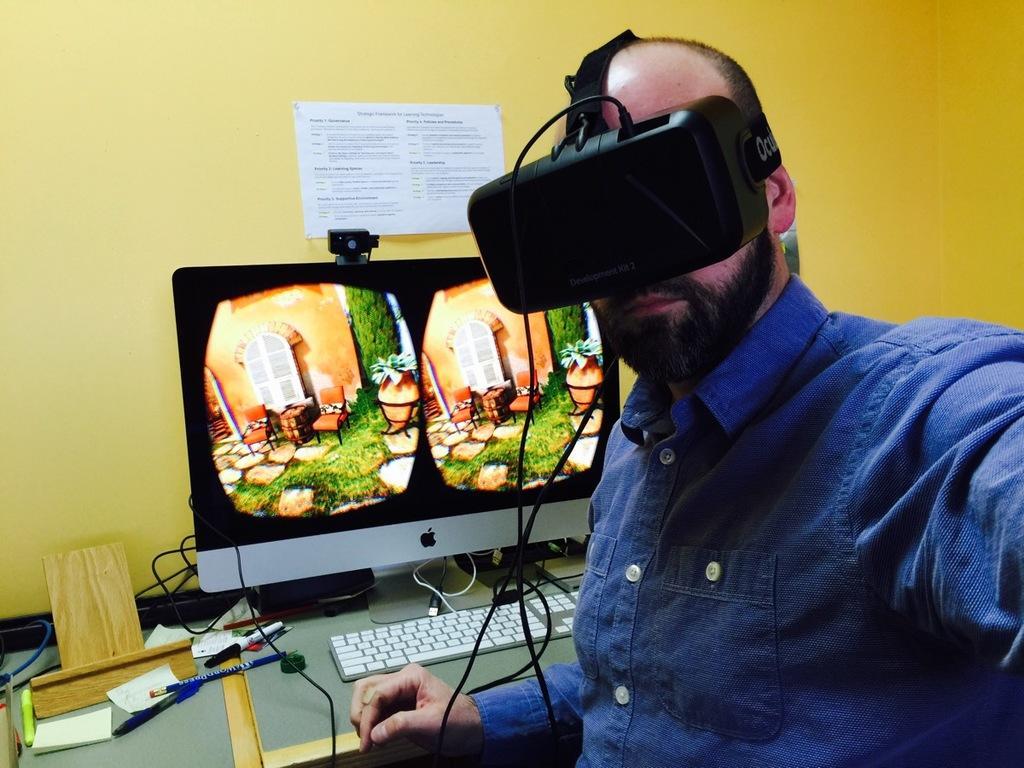Please provide a concise description of this image. In the image at the right side there is a man with blue shirt is sitting and he kept VR box. Beside him there is a table with a monitor, keyboard, papers and few other items. Behind the table there is a yellow color wall with a paper. 